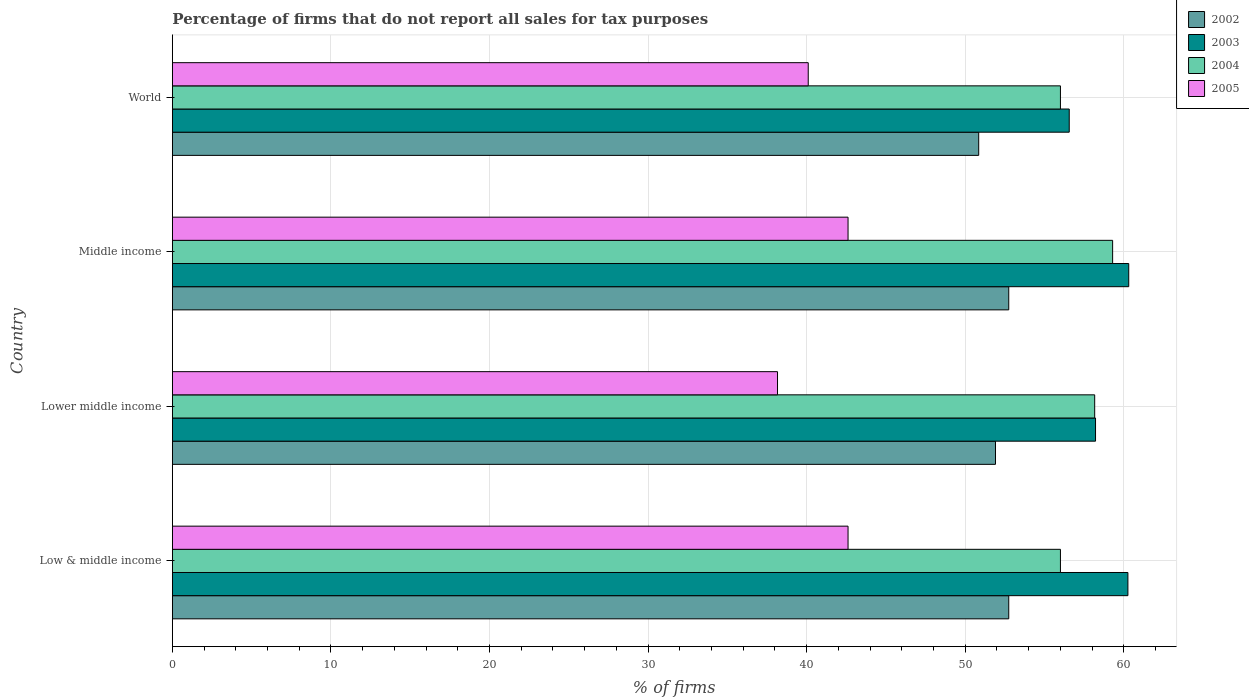How many groups of bars are there?
Offer a terse response. 4. Are the number of bars per tick equal to the number of legend labels?
Give a very brief answer. Yes. Are the number of bars on each tick of the Y-axis equal?
Provide a short and direct response. Yes. How many bars are there on the 1st tick from the top?
Offer a very short reply. 4. In how many cases, is the number of bars for a given country not equal to the number of legend labels?
Your answer should be very brief. 0. What is the percentage of firms that do not report all sales for tax purposes in 2002 in Middle income?
Offer a terse response. 52.75. Across all countries, what is the maximum percentage of firms that do not report all sales for tax purposes in 2005?
Ensure brevity in your answer.  42.61. Across all countries, what is the minimum percentage of firms that do not report all sales for tax purposes in 2005?
Offer a terse response. 38.16. In which country was the percentage of firms that do not report all sales for tax purposes in 2002 maximum?
Provide a succinct answer. Low & middle income. In which country was the percentage of firms that do not report all sales for tax purposes in 2004 minimum?
Provide a short and direct response. Low & middle income. What is the total percentage of firms that do not report all sales for tax purposes in 2003 in the graph?
Your answer should be very brief. 235.35. What is the difference between the percentage of firms that do not report all sales for tax purposes in 2004 in Low & middle income and that in Lower middle income?
Offer a very short reply. -2.16. What is the difference between the percentage of firms that do not report all sales for tax purposes in 2002 in Lower middle income and the percentage of firms that do not report all sales for tax purposes in 2004 in Middle income?
Your answer should be very brief. -7.39. What is the average percentage of firms that do not report all sales for tax purposes in 2003 per country?
Make the answer very short. 58.84. What is the difference between the percentage of firms that do not report all sales for tax purposes in 2002 and percentage of firms that do not report all sales for tax purposes in 2003 in World?
Offer a very short reply. -5.71. In how many countries, is the percentage of firms that do not report all sales for tax purposes in 2002 greater than 58 %?
Make the answer very short. 0. What is the ratio of the percentage of firms that do not report all sales for tax purposes in 2003 in Low & middle income to that in World?
Ensure brevity in your answer.  1.07. What is the difference between the highest and the second highest percentage of firms that do not report all sales for tax purposes in 2003?
Your answer should be very brief. 0.05. What is the difference between the highest and the lowest percentage of firms that do not report all sales for tax purposes in 2003?
Your response must be concise. 3.75. What does the 4th bar from the bottom in Low & middle income represents?
Your response must be concise. 2005. Is it the case that in every country, the sum of the percentage of firms that do not report all sales for tax purposes in 2005 and percentage of firms that do not report all sales for tax purposes in 2002 is greater than the percentage of firms that do not report all sales for tax purposes in 2003?
Keep it short and to the point. Yes. Are all the bars in the graph horizontal?
Keep it short and to the point. Yes. How many countries are there in the graph?
Your answer should be very brief. 4. What is the difference between two consecutive major ticks on the X-axis?
Give a very brief answer. 10. Are the values on the major ticks of X-axis written in scientific E-notation?
Give a very brief answer. No. Does the graph contain grids?
Give a very brief answer. Yes. Where does the legend appear in the graph?
Make the answer very short. Top right. How many legend labels are there?
Keep it short and to the point. 4. How are the legend labels stacked?
Ensure brevity in your answer.  Vertical. What is the title of the graph?
Make the answer very short. Percentage of firms that do not report all sales for tax purposes. Does "1969" appear as one of the legend labels in the graph?
Give a very brief answer. No. What is the label or title of the X-axis?
Your answer should be very brief. % of firms. What is the % of firms in 2002 in Low & middle income?
Offer a terse response. 52.75. What is the % of firms of 2003 in Low & middle income?
Your answer should be compact. 60.26. What is the % of firms in 2004 in Low & middle income?
Your response must be concise. 56.01. What is the % of firms of 2005 in Low & middle income?
Give a very brief answer. 42.61. What is the % of firms of 2002 in Lower middle income?
Provide a short and direct response. 51.91. What is the % of firms of 2003 in Lower middle income?
Keep it short and to the point. 58.22. What is the % of firms of 2004 in Lower middle income?
Your answer should be very brief. 58.16. What is the % of firms of 2005 in Lower middle income?
Your answer should be very brief. 38.16. What is the % of firms in 2002 in Middle income?
Give a very brief answer. 52.75. What is the % of firms in 2003 in Middle income?
Ensure brevity in your answer.  60.31. What is the % of firms of 2004 in Middle income?
Provide a succinct answer. 59.3. What is the % of firms in 2005 in Middle income?
Keep it short and to the point. 42.61. What is the % of firms of 2002 in World?
Offer a very short reply. 50.85. What is the % of firms in 2003 in World?
Ensure brevity in your answer.  56.56. What is the % of firms of 2004 in World?
Ensure brevity in your answer.  56.01. What is the % of firms of 2005 in World?
Provide a succinct answer. 40.1. Across all countries, what is the maximum % of firms of 2002?
Offer a very short reply. 52.75. Across all countries, what is the maximum % of firms in 2003?
Keep it short and to the point. 60.31. Across all countries, what is the maximum % of firms in 2004?
Keep it short and to the point. 59.3. Across all countries, what is the maximum % of firms in 2005?
Keep it short and to the point. 42.61. Across all countries, what is the minimum % of firms in 2002?
Make the answer very short. 50.85. Across all countries, what is the minimum % of firms in 2003?
Make the answer very short. 56.56. Across all countries, what is the minimum % of firms of 2004?
Keep it short and to the point. 56.01. Across all countries, what is the minimum % of firms of 2005?
Your answer should be compact. 38.16. What is the total % of firms of 2002 in the graph?
Your answer should be very brief. 208.25. What is the total % of firms of 2003 in the graph?
Give a very brief answer. 235.35. What is the total % of firms of 2004 in the graph?
Give a very brief answer. 229.47. What is the total % of firms of 2005 in the graph?
Your response must be concise. 163.48. What is the difference between the % of firms of 2002 in Low & middle income and that in Lower middle income?
Your response must be concise. 0.84. What is the difference between the % of firms of 2003 in Low & middle income and that in Lower middle income?
Offer a very short reply. 2.04. What is the difference between the % of firms in 2004 in Low & middle income and that in Lower middle income?
Make the answer very short. -2.16. What is the difference between the % of firms of 2005 in Low & middle income and that in Lower middle income?
Your answer should be compact. 4.45. What is the difference between the % of firms in 2003 in Low & middle income and that in Middle income?
Ensure brevity in your answer.  -0.05. What is the difference between the % of firms in 2004 in Low & middle income and that in Middle income?
Provide a succinct answer. -3.29. What is the difference between the % of firms in 2005 in Low & middle income and that in Middle income?
Your response must be concise. 0. What is the difference between the % of firms of 2002 in Low & middle income and that in World?
Provide a succinct answer. 1.89. What is the difference between the % of firms of 2003 in Low & middle income and that in World?
Offer a very short reply. 3.7. What is the difference between the % of firms of 2004 in Low & middle income and that in World?
Provide a succinct answer. 0. What is the difference between the % of firms in 2005 in Low & middle income and that in World?
Offer a very short reply. 2.51. What is the difference between the % of firms in 2002 in Lower middle income and that in Middle income?
Offer a very short reply. -0.84. What is the difference between the % of firms in 2003 in Lower middle income and that in Middle income?
Keep it short and to the point. -2.09. What is the difference between the % of firms in 2004 in Lower middle income and that in Middle income?
Your answer should be compact. -1.13. What is the difference between the % of firms of 2005 in Lower middle income and that in Middle income?
Offer a terse response. -4.45. What is the difference between the % of firms of 2002 in Lower middle income and that in World?
Keep it short and to the point. 1.06. What is the difference between the % of firms in 2003 in Lower middle income and that in World?
Provide a short and direct response. 1.66. What is the difference between the % of firms in 2004 in Lower middle income and that in World?
Offer a terse response. 2.16. What is the difference between the % of firms in 2005 in Lower middle income and that in World?
Offer a terse response. -1.94. What is the difference between the % of firms in 2002 in Middle income and that in World?
Your response must be concise. 1.89. What is the difference between the % of firms of 2003 in Middle income and that in World?
Your response must be concise. 3.75. What is the difference between the % of firms of 2004 in Middle income and that in World?
Provide a short and direct response. 3.29. What is the difference between the % of firms of 2005 in Middle income and that in World?
Ensure brevity in your answer.  2.51. What is the difference between the % of firms of 2002 in Low & middle income and the % of firms of 2003 in Lower middle income?
Keep it short and to the point. -5.47. What is the difference between the % of firms of 2002 in Low & middle income and the % of firms of 2004 in Lower middle income?
Provide a succinct answer. -5.42. What is the difference between the % of firms in 2002 in Low & middle income and the % of firms in 2005 in Lower middle income?
Your answer should be compact. 14.58. What is the difference between the % of firms in 2003 in Low & middle income and the % of firms in 2004 in Lower middle income?
Give a very brief answer. 2.1. What is the difference between the % of firms of 2003 in Low & middle income and the % of firms of 2005 in Lower middle income?
Provide a succinct answer. 22.1. What is the difference between the % of firms of 2004 in Low & middle income and the % of firms of 2005 in Lower middle income?
Give a very brief answer. 17.84. What is the difference between the % of firms in 2002 in Low & middle income and the % of firms in 2003 in Middle income?
Your response must be concise. -7.57. What is the difference between the % of firms of 2002 in Low & middle income and the % of firms of 2004 in Middle income?
Offer a very short reply. -6.55. What is the difference between the % of firms of 2002 in Low & middle income and the % of firms of 2005 in Middle income?
Your response must be concise. 10.13. What is the difference between the % of firms of 2003 in Low & middle income and the % of firms of 2004 in Middle income?
Provide a short and direct response. 0.96. What is the difference between the % of firms of 2003 in Low & middle income and the % of firms of 2005 in Middle income?
Provide a succinct answer. 17.65. What is the difference between the % of firms of 2004 in Low & middle income and the % of firms of 2005 in Middle income?
Your answer should be very brief. 13.39. What is the difference between the % of firms of 2002 in Low & middle income and the % of firms of 2003 in World?
Give a very brief answer. -3.81. What is the difference between the % of firms of 2002 in Low & middle income and the % of firms of 2004 in World?
Ensure brevity in your answer.  -3.26. What is the difference between the % of firms of 2002 in Low & middle income and the % of firms of 2005 in World?
Offer a terse response. 12.65. What is the difference between the % of firms in 2003 in Low & middle income and the % of firms in 2004 in World?
Provide a short and direct response. 4.25. What is the difference between the % of firms of 2003 in Low & middle income and the % of firms of 2005 in World?
Give a very brief answer. 20.16. What is the difference between the % of firms of 2004 in Low & middle income and the % of firms of 2005 in World?
Ensure brevity in your answer.  15.91. What is the difference between the % of firms in 2002 in Lower middle income and the % of firms in 2003 in Middle income?
Ensure brevity in your answer.  -8.4. What is the difference between the % of firms in 2002 in Lower middle income and the % of firms in 2004 in Middle income?
Provide a succinct answer. -7.39. What is the difference between the % of firms of 2002 in Lower middle income and the % of firms of 2005 in Middle income?
Your answer should be very brief. 9.3. What is the difference between the % of firms in 2003 in Lower middle income and the % of firms in 2004 in Middle income?
Offer a terse response. -1.08. What is the difference between the % of firms in 2003 in Lower middle income and the % of firms in 2005 in Middle income?
Keep it short and to the point. 15.61. What is the difference between the % of firms in 2004 in Lower middle income and the % of firms in 2005 in Middle income?
Your answer should be very brief. 15.55. What is the difference between the % of firms in 2002 in Lower middle income and the % of firms in 2003 in World?
Make the answer very short. -4.65. What is the difference between the % of firms of 2002 in Lower middle income and the % of firms of 2004 in World?
Provide a succinct answer. -4.1. What is the difference between the % of firms of 2002 in Lower middle income and the % of firms of 2005 in World?
Ensure brevity in your answer.  11.81. What is the difference between the % of firms of 2003 in Lower middle income and the % of firms of 2004 in World?
Offer a terse response. 2.21. What is the difference between the % of firms in 2003 in Lower middle income and the % of firms in 2005 in World?
Make the answer very short. 18.12. What is the difference between the % of firms in 2004 in Lower middle income and the % of firms in 2005 in World?
Your answer should be very brief. 18.07. What is the difference between the % of firms of 2002 in Middle income and the % of firms of 2003 in World?
Provide a succinct answer. -3.81. What is the difference between the % of firms in 2002 in Middle income and the % of firms in 2004 in World?
Your response must be concise. -3.26. What is the difference between the % of firms in 2002 in Middle income and the % of firms in 2005 in World?
Give a very brief answer. 12.65. What is the difference between the % of firms of 2003 in Middle income and the % of firms of 2004 in World?
Offer a very short reply. 4.31. What is the difference between the % of firms in 2003 in Middle income and the % of firms in 2005 in World?
Offer a terse response. 20.21. What is the difference between the % of firms in 2004 in Middle income and the % of firms in 2005 in World?
Keep it short and to the point. 19.2. What is the average % of firms in 2002 per country?
Your response must be concise. 52.06. What is the average % of firms in 2003 per country?
Provide a succinct answer. 58.84. What is the average % of firms in 2004 per country?
Your answer should be compact. 57.37. What is the average % of firms of 2005 per country?
Your answer should be very brief. 40.87. What is the difference between the % of firms of 2002 and % of firms of 2003 in Low & middle income?
Make the answer very short. -7.51. What is the difference between the % of firms in 2002 and % of firms in 2004 in Low & middle income?
Offer a terse response. -3.26. What is the difference between the % of firms of 2002 and % of firms of 2005 in Low & middle income?
Your answer should be compact. 10.13. What is the difference between the % of firms in 2003 and % of firms in 2004 in Low & middle income?
Ensure brevity in your answer.  4.25. What is the difference between the % of firms of 2003 and % of firms of 2005 in Low & middle income?
Provide a short and direct response. 17.65. What is the difference between the % of firms in 2004 and % of firms in 2005 in Low & middle income?
Your answer should be very brief. 13.39. What is the difference between the % of firms of 2002 and % of firms of 2003 in Lower middle income?
Offer a very short reply. -6.31. What is the difference between the % of firms in 2002 and % of firms in 2004 in Lower middle income?
Make the answer very short. -6.26. What is the difference between the % of firms of 2002 and % of firms of 2005 in Lower middle income?
Provide a short and direct response. 13.75. What is the difference between the % of firms of 2003 and % of firms of 2004 in Lower middle income?
Offer a terse response. 0.05. What is the difference between the % of firms of 2003 and % of firms of 2005 in Lower middle income?
Your answer should be compact. 20.06. What is the difference between the % of firms in 2004 and % of firms in 2005 in Lower middle income?
Give a very brief answer. 20. What is the difference between the % of firms of 2002 and % of firms of 2003 in Middle income?
Offer a terse response. -7.57. What is the difference between the % of firms of 2002 and % of firms of 2004 in Middle income?
Offer a terse response. -6.55. What is the difference between the % of firms of 2002 and % of firms of 2005 in Middle income?
Provide a succinct answer. 10.13. What is the difference between the % of firms of 2003 and % of firms of 2004 in Middle income?
Give a very brief answer. 1.02. What is the difference between the % of firms in 2003 and % of firms in 2005 in Middle income?
Your answer should be very brief. 17.7. What is the difference between the % of firms of 2004 and % of firms of 2005 in Middle income?
Keep it short and to the point. 16.69. What is the difference between the % of firms in 2002 and % of firms in 2003 in World?
Make the answer very short. -5.71. What is the difference between the % of firms in 2002 and % of firms in 2004 in World?
Your response must be concise. -5.15. What is the difference between the % of firms of 2002 and % of firms of 2005 in World?
Provide a short and direct response. 10.75. What is the difference between the % of firms of 2003 and % of firms of 2004 in World?
Give a very brief answer. 0.56. What is the difference between the % of firms of 2003 and % of firms of 2005 in World?
Provide a succinct answer. 16.46. What is the difference between the % of firms of 2004 and % of firms of 2005 in World?
Your answer should be compact. 15.91. What is the ratio of the % of firms in 2002 in Low & middle income to that in Lower middle income?
Offer a very short reply. 1.02. What is the ratio of the % of firms in 2003 in Low & middle income to that in Lower middle income?
Give a very brief answer. 1.04. What is the ratio of the % of firms in 2004 in Low & middle income to that in Lower middle income?
Offer a terse response. 0.96. What is the ratio of the % of firms of 2005 in Low & middle income to that in Lower middle income?
Give a very brief answer. 1.12. What is the ratio of the % of firms in 2002 in Low & middle income to that in Middle income?
Provide a succinct answer. 1. What is the ratio of the % of firms of 2003 in Low & middle income to that in Middle income?
Offer a very short reply. 1. What is the ratio of the % of firms of 2004 in Low & middle income to that in Middle income?
Give a very brief answer. 0.94. What is the ratio of the % of firms of 2005 in Low & middle income to that in Middle income?
Your response must be concise. 1. What is the ratio of the % of firms of 2002 in Low & middle income to that in World?
Your answer should be very brief. 1.04. What is the ratio of the % of firms in 2003 in Low & middle income to that in World?
Your response must be concise. 1.07. What is the ratio of the % of firms of 2004 in Low & middle income to that in World?
Your answer should be compact. 1. What is the ratio of the % of firms in 2005 in Low & middle income to that in World?
Your answer should be very brief. 1.06. What is the ratio of the % of firms in 2002 in Lower middle income to that in Middle income?
Make the answer very short. 0.98. What is the ratio of the % of firms of 2003 in Lower middle income to that in Middle income?
Offer a very short reply. 0.97. What is the ratio of the % of firms in 2004 in Lower middle income to that in Middle income?
Offer a terse response. 0.98. What is the ratio of the % of firms of 2005 in Lower middle income to that in Middle income?
Make the answer very short. 0.9. What is the ratio of the % of firms of 2002 in Lower middle income to that in World?
Offer a very short reply. 1.02. What is the ratio of the % of firms in 2003 in Lower middle income to that in World?
Provide a short and direct response. 1.03. What is the ratio of the % of firms in 2004 in Lower middle income to that in World?
Give a very brief answer. 1.04. What is the ratio of the % of firms of 2005 in Lower middle income to that in World?
Make the answer very short. 0.95. What is the ratio of the % of firms in 2002 in Middle income to that in World?
Ensure brevity in your answer.  1.04. What is the ratio of the % of firms of 2003 in Middle income to that in World?
Your answer should be very brief. 1.07. What is the ratio of the % of firms in 2004 in Middle income to that in World?
Give a very brief answer. 1.06. What is the ratio of the % of firms in 2005 in Middle income to that in World?
Make the answer very short. 1.06. What is the difference between the highest and the second highest % of firms of 2002?
Offer a very short reply. 0. What is the difference between the highest and the second highest % of firms in 2003?
Your answer should be compact. 0.05. What is the difference between the highest and the second highest % of firms of 2004?
Provide a short and direct response. 1.13. What is the difference between the highest and the second highest % of firms of 2005?
Your response must be concise. 0. What is the difference between the highest and the lowest % of firms in 2002?
Make the answer very short. 1.89. What is the difference between the highest and the lowest % of firms of 2003?
Make the answer very short. 3.75. What is the difference between the highest and the lowest % of firms in 2004?
Your answer should be very brief. 3.29. What is the difference between the highest and the lowest % of firms in 2005?
Keep it short and to the point. 4.45. 